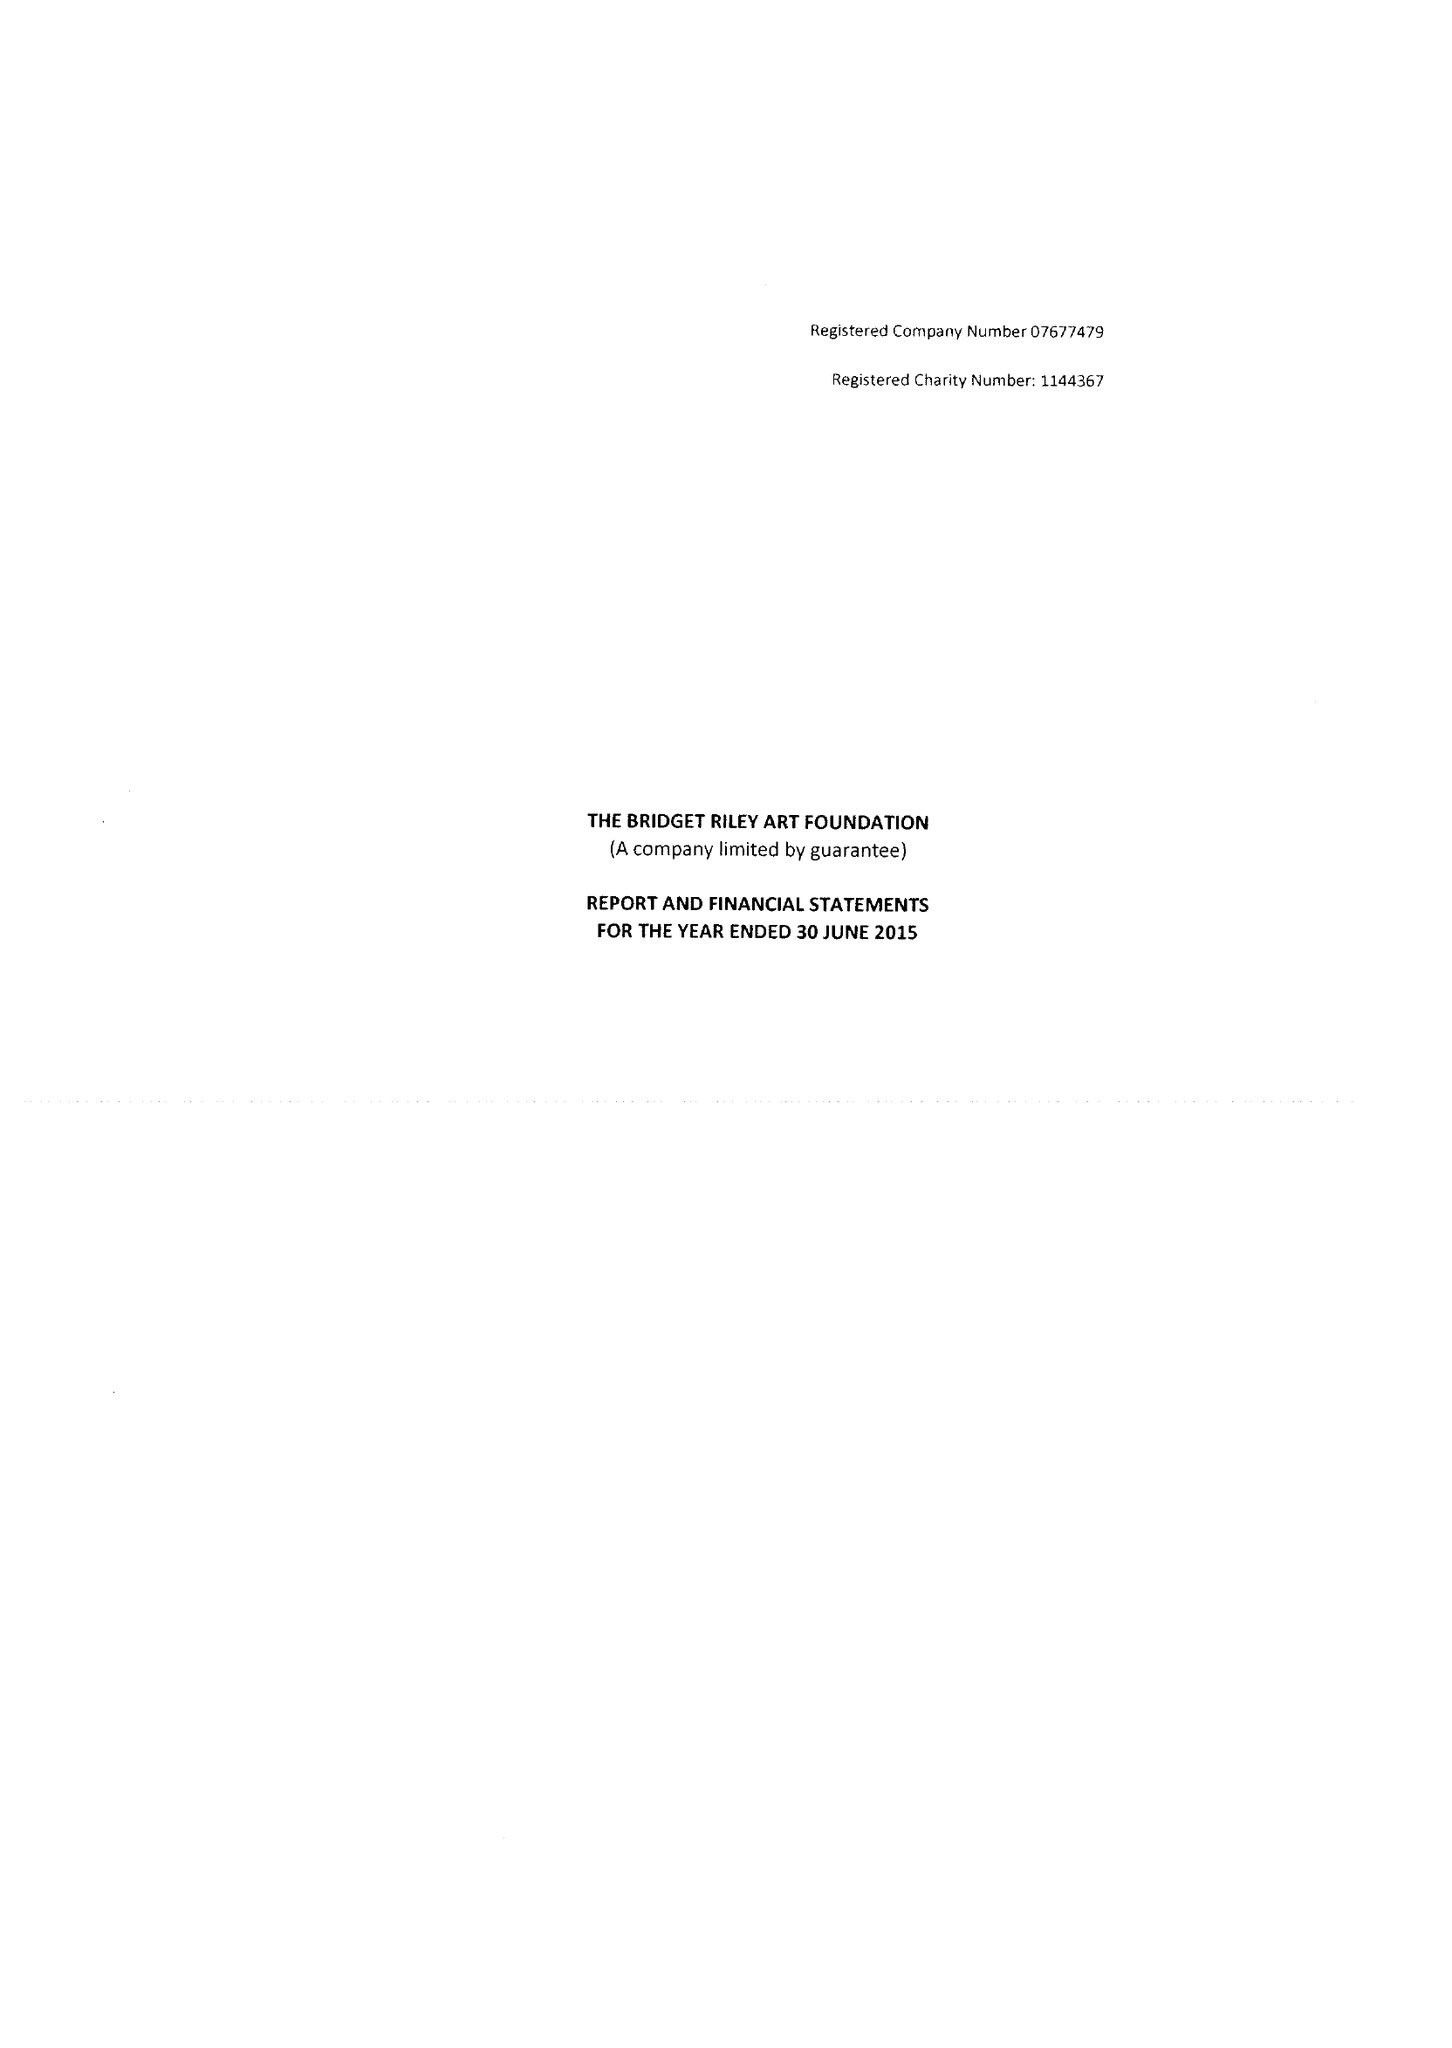What is the value for the income_annually_in_british_pounds?
Answer the question using a single word or phrase. 560588.00 